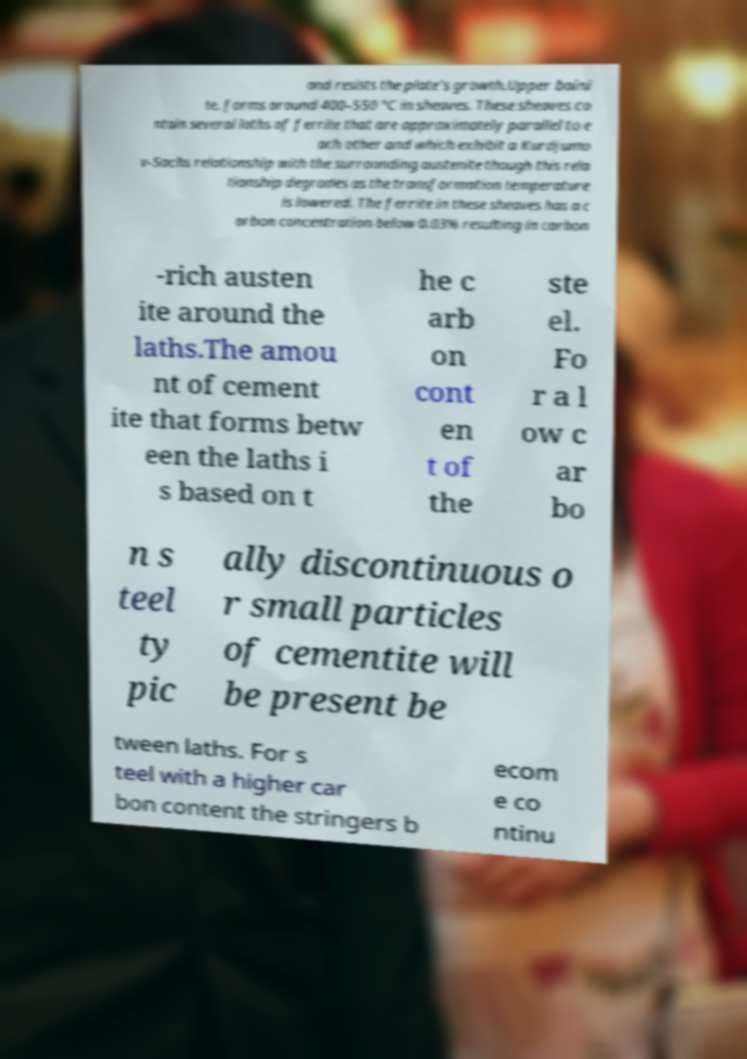Can you accurately transcribe the text from the provided image for me? and resists the plate's growth.Upper baini te. forms around 400–550 °C in sheaves. These sheaves co ntain several laths of ferrite that are approximately parallel to e ach other and which exhibit a Kurdjumo v-Sachs relationship with the surrounding austenite though this rela tionship degrades as the transformation temperature is lowered. The ferrite in these sheaves has a c arbon concentration below 0.03% resulting in carbon -rich austen ite around the laths.The amou nt of cement ite that forms betw een the laths i s based on t he c arb on cont en t of the ste el. Fo r a l ow c ar bo n s teel ty pic ally discontinuous o r small particles of cementite will be present be tween laths. For s teel with a higher car bon content the stringers b ecom e co ntinu 